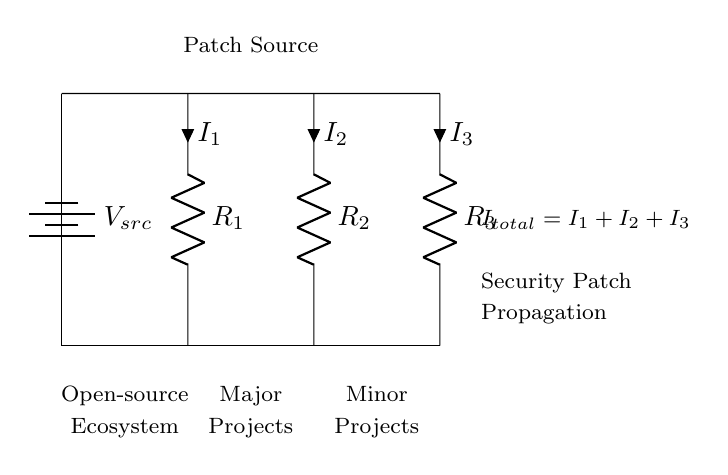What is the source voltage in the circuit? The source voltage is indicated by the label $V_{src}$ at the top of the circuit diagram. It represents the potential difference provided by the battery connected to the circuit.
Answer: V_src How many resistors are present in the current divider? The circuit diagram depicts three resistors: $R_1$, $R_2$, and $R_3$, each labeled in the circuit with their respective positions.
Answer: 3 What does the total current in the circuit represent? The total current, denoted as $I_{total}$, is the sum of the individual currents $I_1$, $I_2$, and $I_3$ flowing through each resistor. This is a fundamental concept in current dividers, showing how current splits based on resistance values.
Answer: I_1 + I_2 + I_3 Which components represent major and minor open-source projects? Major projects are represented by $R_1$ and minor projects by $R_2$ and $R_3$ as labeled in the nodes of the diagram. This is significant in understanding the distribution of current, which reflects the importance and resource allocation to these projects.
Answer: R_1 (major), R_2 and R_3 (minor) How does the current divide among the resistors in this circuit? In a current divider, the current is inversely proportional to the resistance. This means that a lower resistance will have a larger share of the total current, while a higher resistance will have a smaller share. This principle is visually represented through the currents $I_1$, $I_2$, and $I_3$ shown adjacent to each resistor.
Answer: Inverse proportion to resistance What does the node labeled "Patch Source" imply in the context of security patches? The "Patch Source" node signifies the origin of the security patches in an open-source ecosystem. It can be interpreted that these patches will propagate through the major and minor projects in the ecosystem, analogous to how current travels through the circuit based on the paths defined by the resistors.
Answer: Origin of security patches 